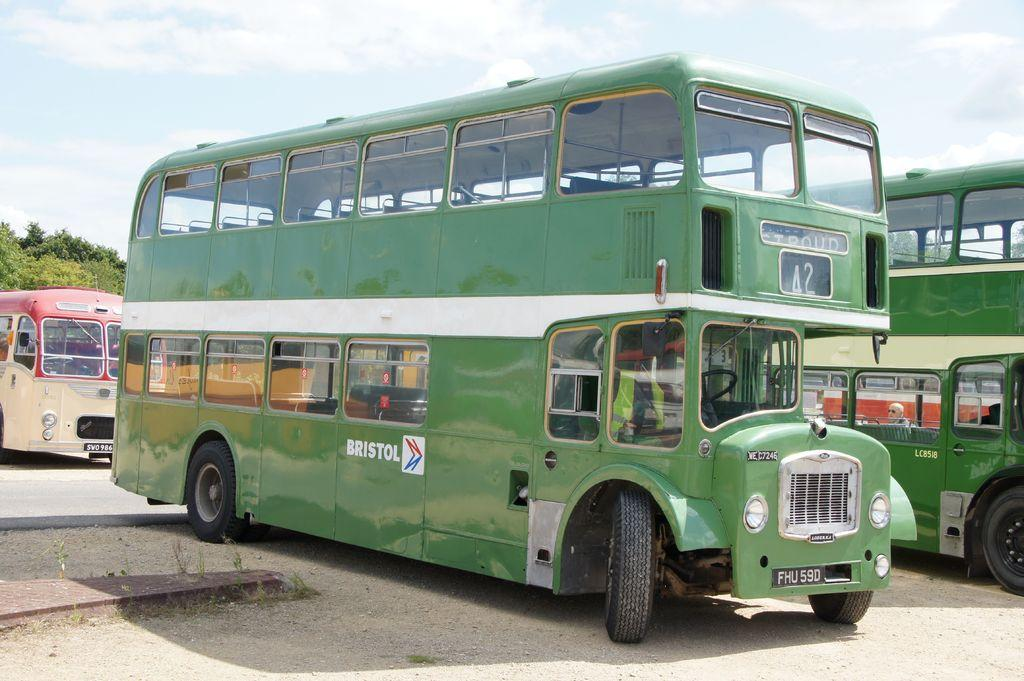<image>
Create a compact narrative representing the image presented. A green bus with Bristol written on the side 